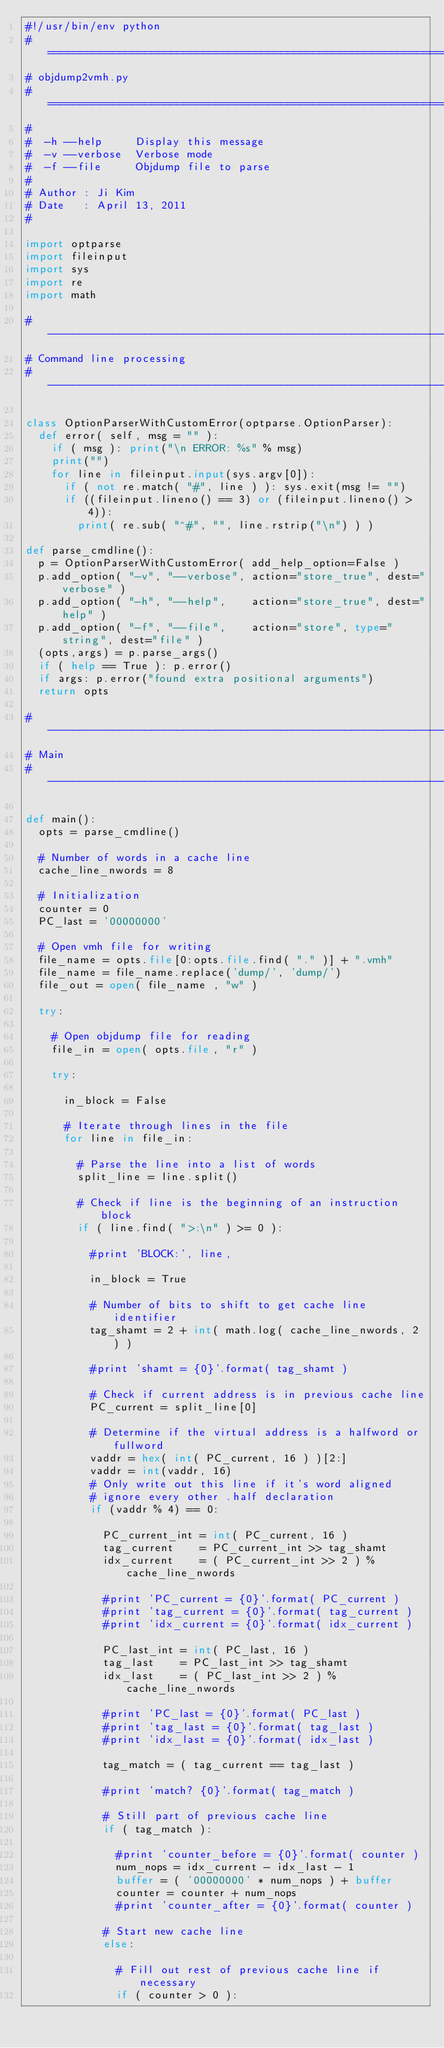<code> <loc_0><loc_0><loc_500><loc_500><_Python_>#!/usr/bin/env python
#===============================================================================
# objdump2vmh.py
#===============================================================================
#
#  -h --help     Display this message
#  -v --verbose  Verbose mode
#  -f --file     Objdump file to parse
#
# Author : Ji Kim
# Date   : April 13, 2011
#

import optparse
import fileinput
import sys
import re
import math

#-------------------------------------------------------------------------------
# Command line processing
#-------------------------------------------------------------------------------

class OptionParserWithCustomError(optparse.OptionParser):
  def error( self, msg = "" ):
    if ( msg ): print("\n ERROR: %s" % msg)
    print("")
    for line in fileinput.input(sys.argv[0]):
      if ( not re.match( "#", line ) ): sys.exit(msg != "")
      if ((fileinput.lineno() == 3) or (fileinput.lineno() > 4)):
        print( re.sub( "^#", "", line.rstrip("\n") ) )

def parse_cmdline():
  p = OptionParserWithCustomError( add_help_option=False )
  p.add_option( "-v", "--verbose", action="store_true", dest="verbose" )
  p.add_option( "-h", "--help",    action="store_true", dest="help" )
  p.add_option( "-f", "--file",    action="store", type="string", dest="file" )
  (opts,args) = p.parse_args()
  if ( help == True ): p.error()
  if args: p.error("found extra positional arguments")
  return opts

#-------------------------------------------------------------------------------
# Main
#-------------------------------------------------------------------------------

def main():
  opts = parse_cmdline()

  # Number of words in a cache line
  cache_line_nwords = 8

  # Initialization
  counter = 0
  PC_last = '00000000'

  # Open vmh file for writing
  file_name = opts.file[0:opts.file.find( "." )] + ".vmh"
  file_name = file_name.replace('dump/', 'dump/')
  file_out = open( file_name , "w" )

  try:

    # Open objdump file for reading
    file_in = open( opts.file, "r" )

    try:

      in_block = False

      # Iterate through lines in the file
      for line in file_in:

        # Parse the line into a list of words
        split_line = line.split()

        # Check if line is the beginning of an instruction block
        if ( line.find( ">:\n" ) >= 0 ):

          #print 'BLOCK:', line,

          in_block = True

          # Number of bits to shift to get cache line identifier
          tag_shamt = 2 + int( math.log( cache_line_nwords, 2 ) )

          #print 'shamt = {0}'.format( tag_shamt )

          # Check if current address is in previous cache line
          PC_current = split_line[0]

          # Determine if the virtual address is a halfword or fullword
          vaddr = hex( int( PC_current, 16 ) )[2:]
          vaddr = int(vaddr, 16)
          # Only write out this line if it's word aligned
          # ignore every other .half declaration
          if (vaddr % 4) == 0:

            PC_current_int = int( PC_current, 16 )
            tag_current    = PC_current_int >> tag_shamt
            idx_current    = ( PC_current_int >> 2 ) % cache_line_nwords

            #print 'PC_current = {0}'.format( PC_current )
            #print 'tag_current = {0}'.format( tag_current )
            #print 'idx_current = {0}'.format( idx_current )

            PC_last_int = int( PC_last, 16 )
            tag_last    = PC_last_int >> tag_shamt
            idx_last    = ( PC_last_int >> 2 ) % cache_line_nwords

            #print 'PC_last = {0}'.format( PC_last )
            #print 'tag_last = {0}'.format( tag_last )
            #print 'idx_last = {0}'.format( idx_last )

            tag_match = ( tag_current == tag_last )

            #print 'match? {0}'.format( tag_match )

            # Still part of previous cache line
            if ( tag_match ):

              #print 'counter_before = {0}'.format( counter )
              num_nops = idx_current - idx_last - 1
              buffer = ( '00000000' * num_nops ) + buffer
              counter = counter + num_nops
              #print 'counter_after = {0}'.format( counter )

            # Start new cache line
            else:

              # Fill out rest of previous cache line if necessary
              if ( counter > 0 ):</code> 